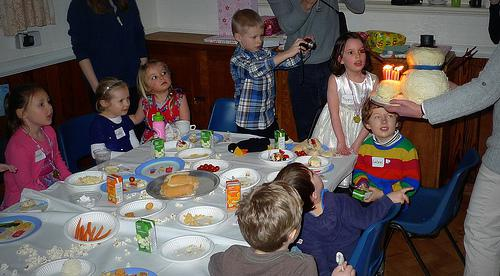Question: what is the color of the tablecloth?
Choices:
A. Red.
B. Blue.
C. White.
D. Green.
Answer with the letter. Answer: C Question: how many children are there?
Choices:
A. 9.
B. 10.
C. 8.
D. 11.
Answer with the letter. Answer: C Question: what is the color of the shelf?
Choices:
A. Black.
B. Brown.
C. White.
D. Blue.
Answer with the letter. Answer: B Question: what is the color of the chair?
Choices:
A. Red.
B. Yellow.
C. Black.
D. Blue.
Answer with the letter. Answer: D Question: what is in the tray?
Choices:
A. Bread.
B. Cake.
C. Crackers.
D. Noodles.
Answer with the letter. Answer: B 